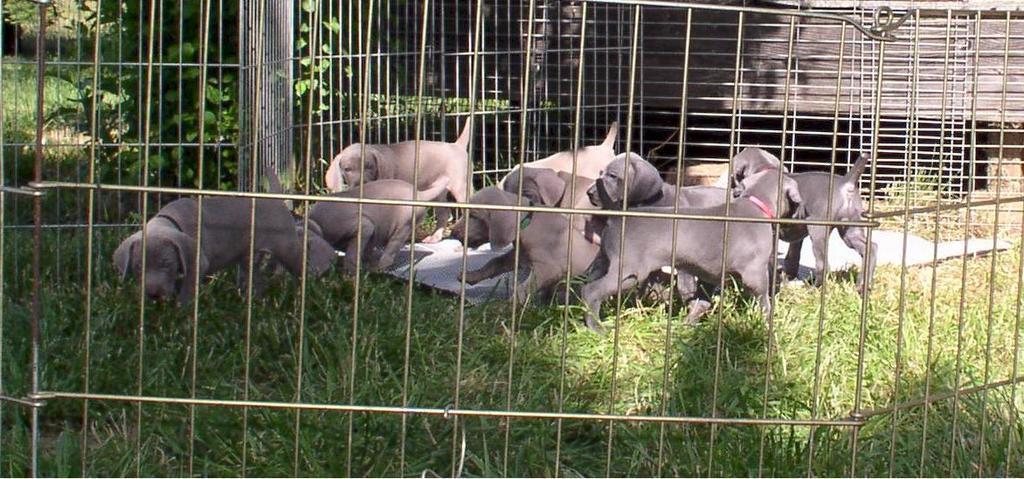In one or two sentences, can you explain what this image depicts? In this image there are group of dogs playing on the ground. They are kept in the metal cage. At the bottom there is grass. In the background it looks like a wooden wall. 